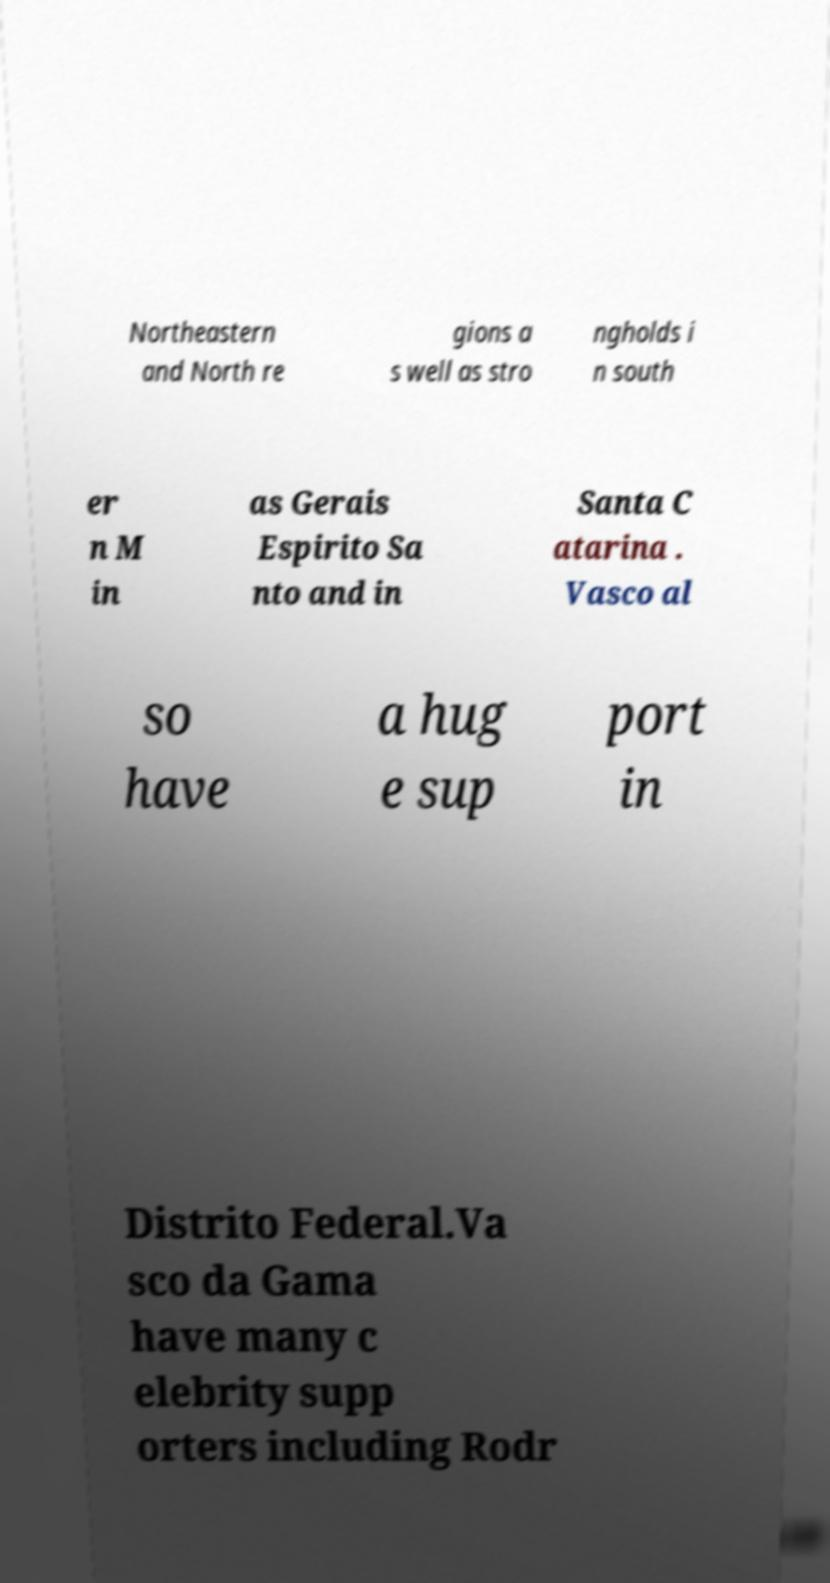Could you extract and type out the text from this image? Northeastern and North re gions a s well as stro ngholds i n south er n M in as Gerais Espirito Sa nto and in Santa C atarina . Vasco al so have a hug e sup port in Distrito Federal.Va sco da Gama have many c elebrity supp orters including Rodr 